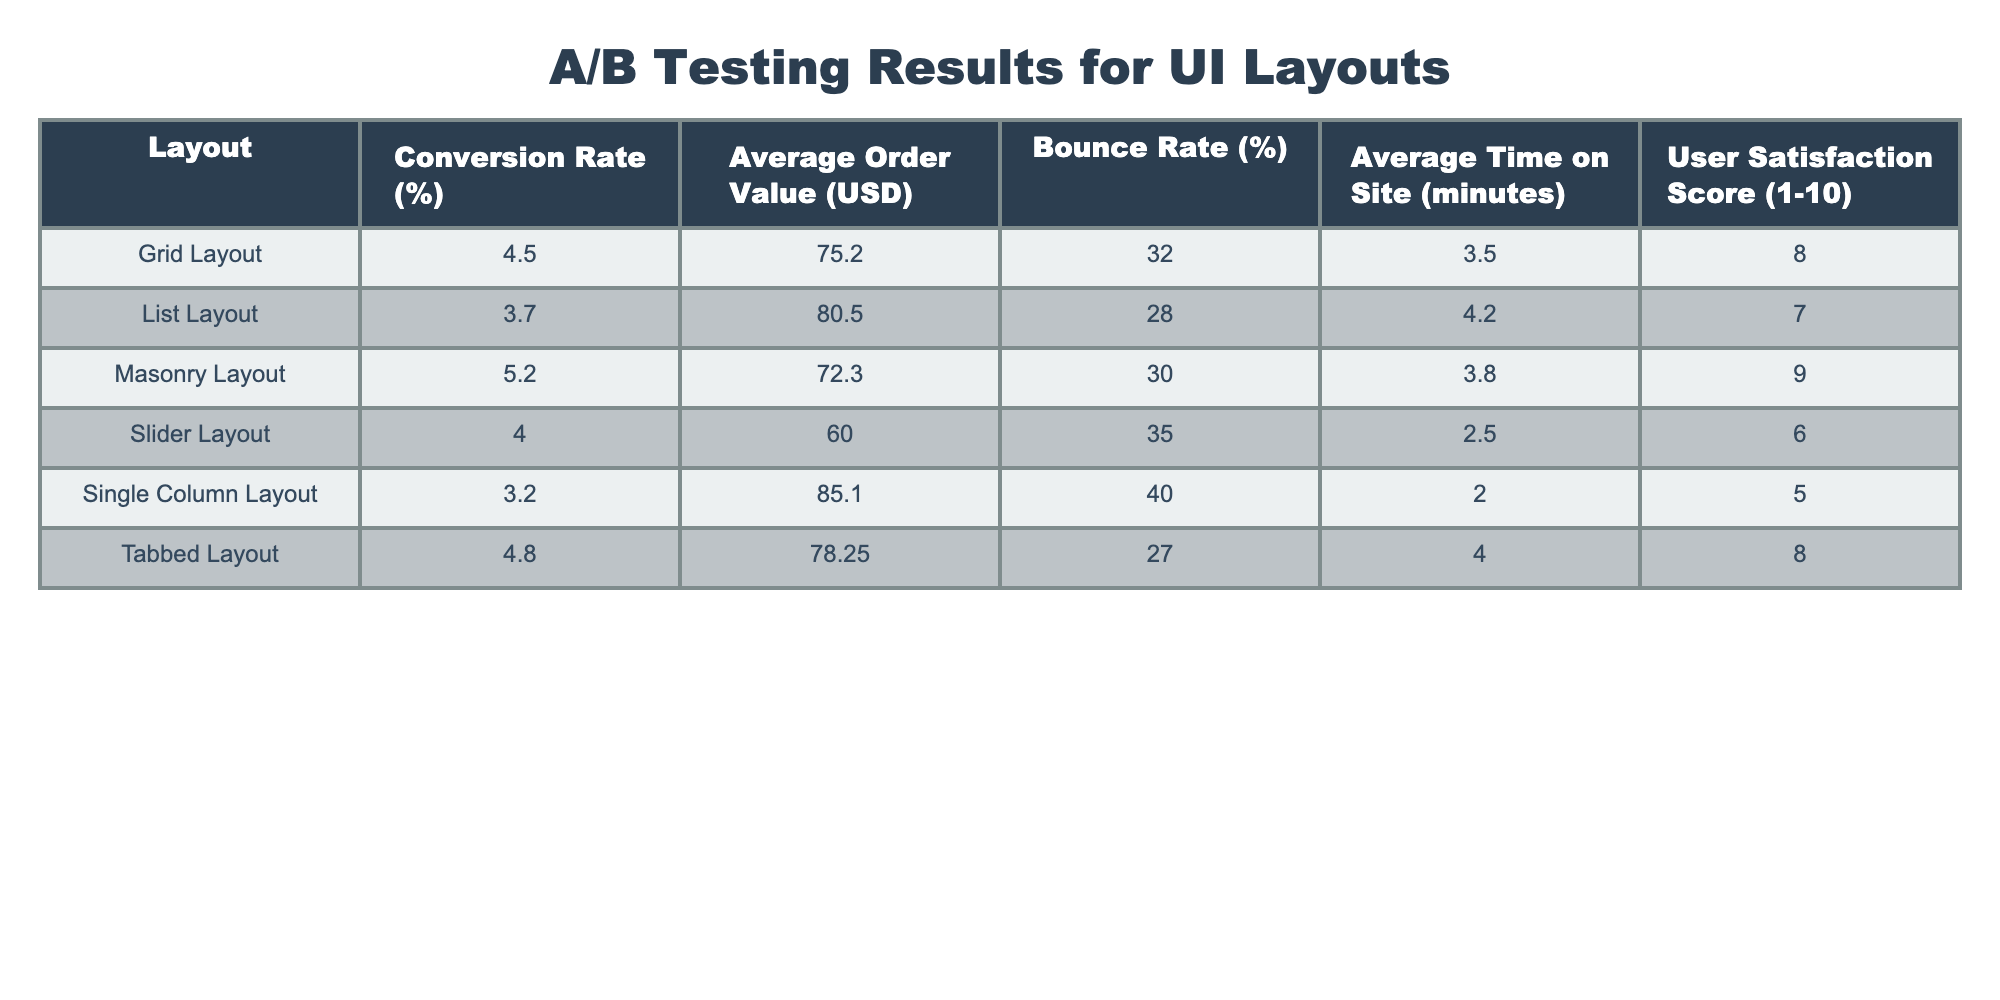What is the conversion rate for the Masonry Layout? From the table, the Masonry Layout has a Conversion Rate of 5.2%.
Answer: 5.2% Which layout has the lowest Average Order Value? Looking at the Average Order Value column, the Slider Layout shows the lowest value at 60.00 USD.
Answer: 60.00 USD What is the average Bounce Rate for all layouts combined? To find the average Bounce Rate, we sum the Bounce Rates of all layouts: (32 + 28 + 30 + 35 + 40 + 27) = 192. Then, dividing by the number of layouts (6): 192 / 6 = 32.
Answer: 32% Is the User Satisfaction Score for the Grid Layout higher than for the Slider Layout? The Grid Layout has a User Satisfaction Score of 8, while the Slider Layout has a score of 6. Since 8 > 6, the statement is true.
Answer: Yes Which layout has the highest Average Time on Site? Examining the Average Time on Site column, the List Layout exhibits the highest time at 4.2 minutes.
Answer: 4.2 minutes What’s the overall trend in Conversion Rates among the layouts from highest to lowest? The layouts sorted by Conversion Rate are: Masonry Layout (5.2%), Tabbed Layout (4.8%), Grid Layout (4.5%), Slider Layout (4.0%), List Layout (3.7%), Single Column Layout (3.2%). This indicates a decreasing trend from Masonry to Single Column.
Answer: Decreasing trend from Masonry to Single Column Is the Bounce Rate for the Tabbed Layout lower than the average Bounce Rate of all layouts? The average Bounce Rate calculated earlier is 32%. The Bounce Rate for the Tabbed Layout is 27%, which is indeed lower than 32%. Thus, the statement is true.
Answer: Yes What is the difference in Conversion Rate between the Grid Layout and Single Column Layout? The Conversion Rate for the Grid Layout is 4.5% whereas for the Single Column Layout it is 3.2%. The difference is 4.5% - 3.2% = 1.3%.
Answer: 1.3% 